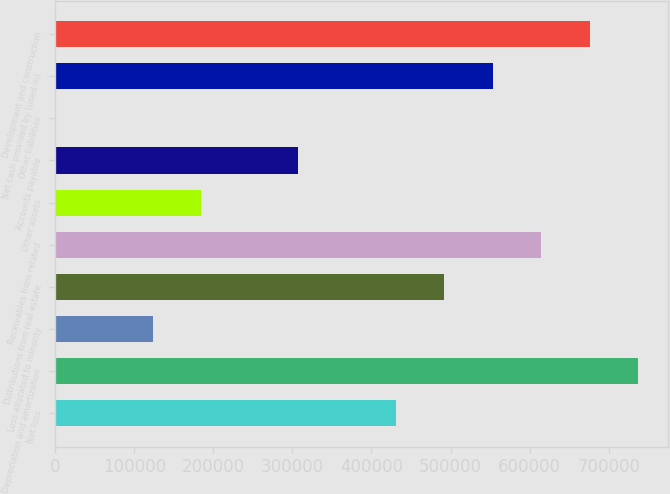Convert chart. <chart><loc_0><loc_0><loc_500><loc_500><bar_chart><fcel>Net loss<fcel>Depreciation and amortization<fcel>Loss allocated to minority<fcel>Distributions from real estate<fcel>Receivables from related<fcel>Other assets<fcel>Accounts payable<fcel>Other liabilities<fcel>Net cash provided by (used in)<fcel>Development and construction<nl><fcel>430468<fcel>737745<fcel>123191<fcel>491923<fcel>614834<fcel>184646<fcel>307557<fcel>280<fcel>553379<fcel>676289<nl></chart> 